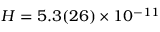<formula> <loc_0><loc_0><loc_500><loc_500>H = 5 . 3 ( 2 6 ) \times 1 0 ^ { - 1 1 }</formula> 